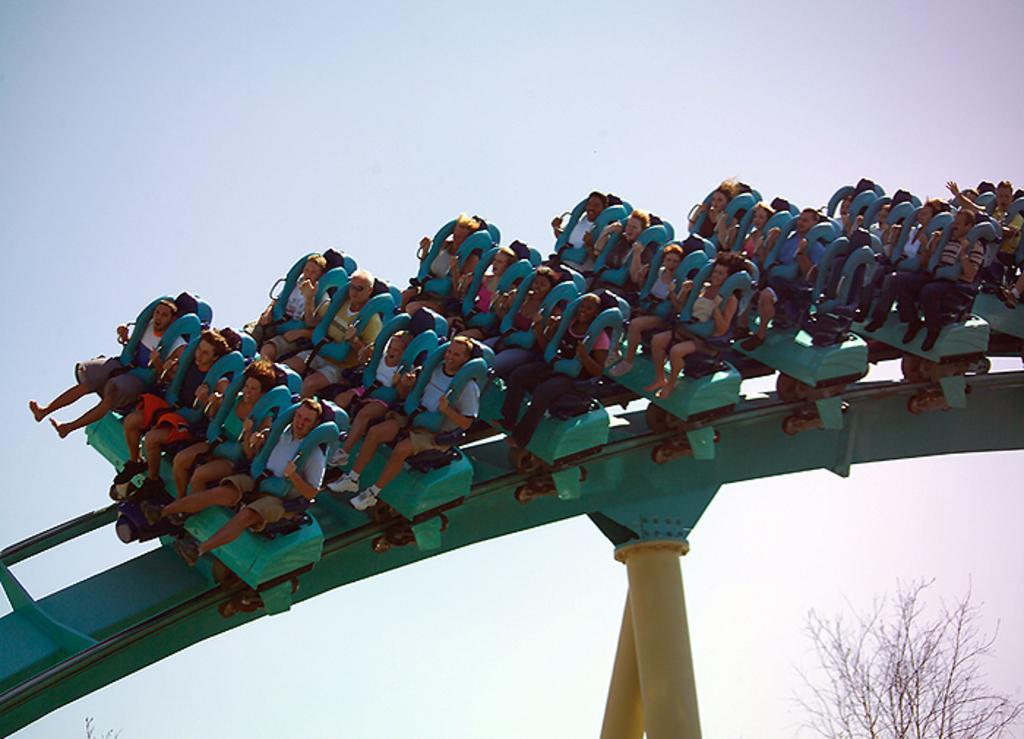In one or two sentences, can you explain what this image depicts? In this image in the center there are persons sitting on a roller coaster and there is a dry tree. 